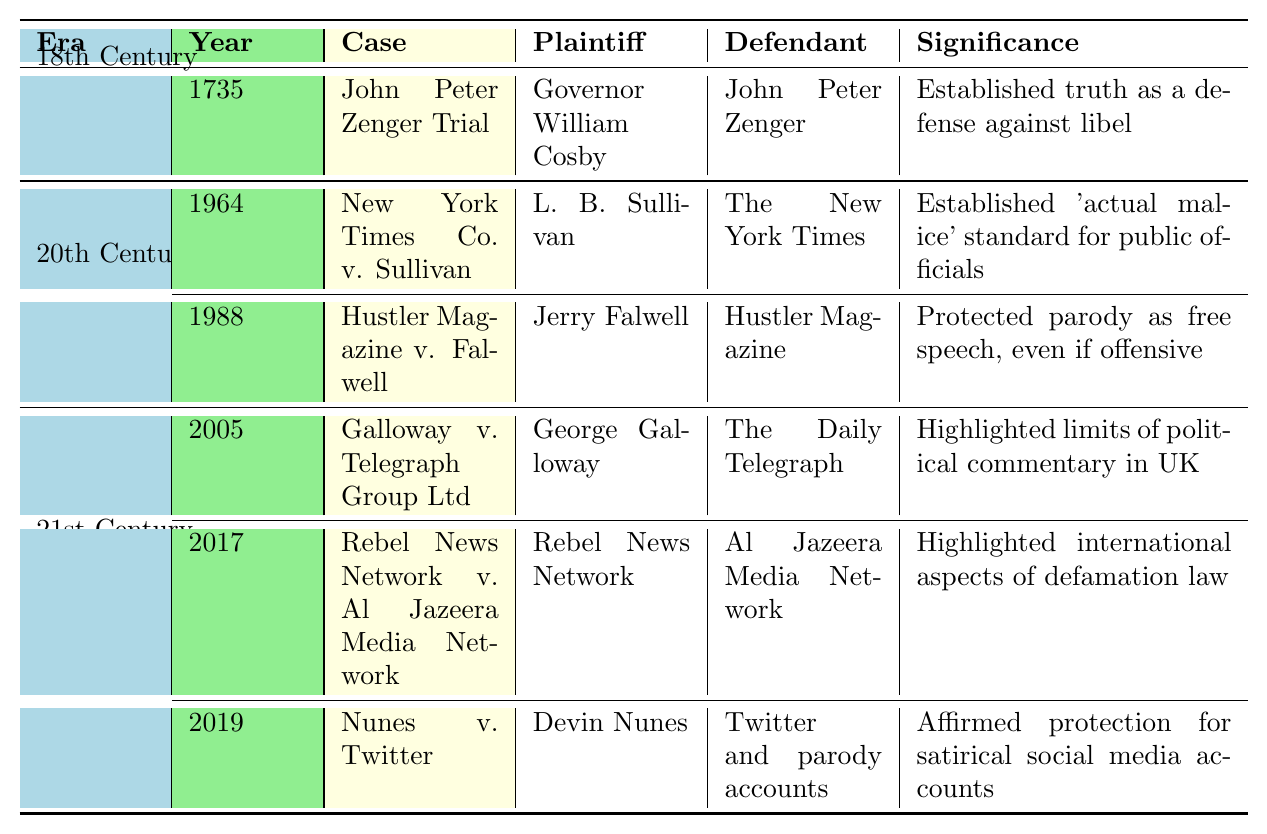What was the outcome of the John Peter Zenger Trial? The table states that the outcome of the John Peter Zenger Trial in 1735 was an "Acquittal".
Answer: Acquittal What significance does the New York Times Co. v. Sullivan case hold? According to the table, the significance of the New York Times Co. v. Sullivan case is that it established the "actual malice" standard for public officials.
Answer: Established 'actual malice' standard for public officials How many cases are listed from the 21st Century? There are three cases listed from the 21st Century: Galloway v. Telegraph Group Ltd, Rebel News Network v. Al Jazeera Media Network, and Nunes v. Twitter.
Answer: Three Which case involved Jerry Falwell as the plaintiff? The table shows that Jerry Falwell was the plaintiff in the Hustler Magazine v. Falwell case in 1988.
Answer: Hustler Magazine v. Falwell Is it true that the Galloway v. Telegraph Group Ltd case ruled in favor of the defendant? The table indicates that the Galloway v. Telegraph Group Ltd case actually ruled in favor of the plaintiff, which means the statement is false.
Answer: False What does the significance of the Hustler Magazine v. Falwell case imply about political satire? The significance states that it protected parody as free speech, even if offensive, indicating that political satire is legally safeguarded under the law.
Answer: Protected parody as free speech During which century did the John Peter Zenger Trial take place, and what was its significant impact? The John Peter Zenger Trial took place in the 18th Century, and it established truth as a defense against libel, which was a significant impact on defamation law.
Answer: 18th Century; established truth as defense against libel How does the outcome of Nunes v. Twitter impact satirical social media accounts? The case was dismissed which affirms protection for satirical social media accounts, important for freedom of expression in that medium.
Answer: Affirmed protection for satirical social media accounts What is the trend in the outcomes for plaintiffs in the listed cases? Out of the cases listed, the trend shows that the outcomes for plaintiffs are mixed: they won in Galloway v. Telegraph Group Ltd, lost in Nunes v. Twitter, and settled in Rebel News Network v. Al Jazeera Media Network, indicating varied success.
Answer: Mixed outcomes What year did the case regarding the Daily Telegraph occur, and what does it illustrate about political commentary limits in the UK? The Galloway v. Telegraph Group Ltd occurred in 2005 and illustrates the limits of political commentary in the UK as highlighted by the ruling in favor of the plaintiff.
Answer: 2005; highlighted limits of political commentary in UK 